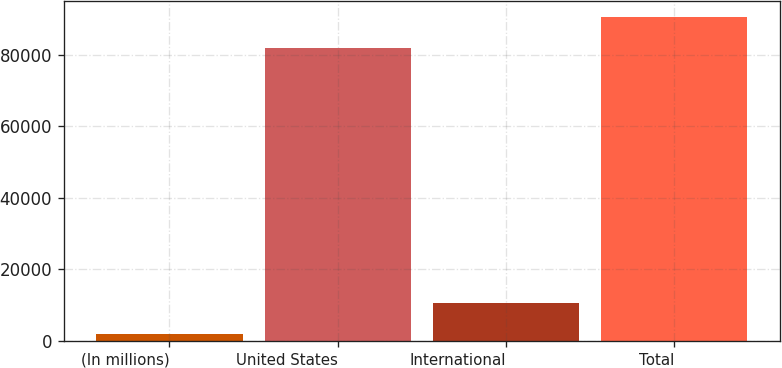<chart> <loc_0><loc_0><loc_500><loc_500><bar_chart><fcel>(In millions)<fcel>United States<fcel>International<fcel>Total<nl><fcel>2006<fcel>81935<fcel>10610.4<fcel>90539.4<nl></chart> 